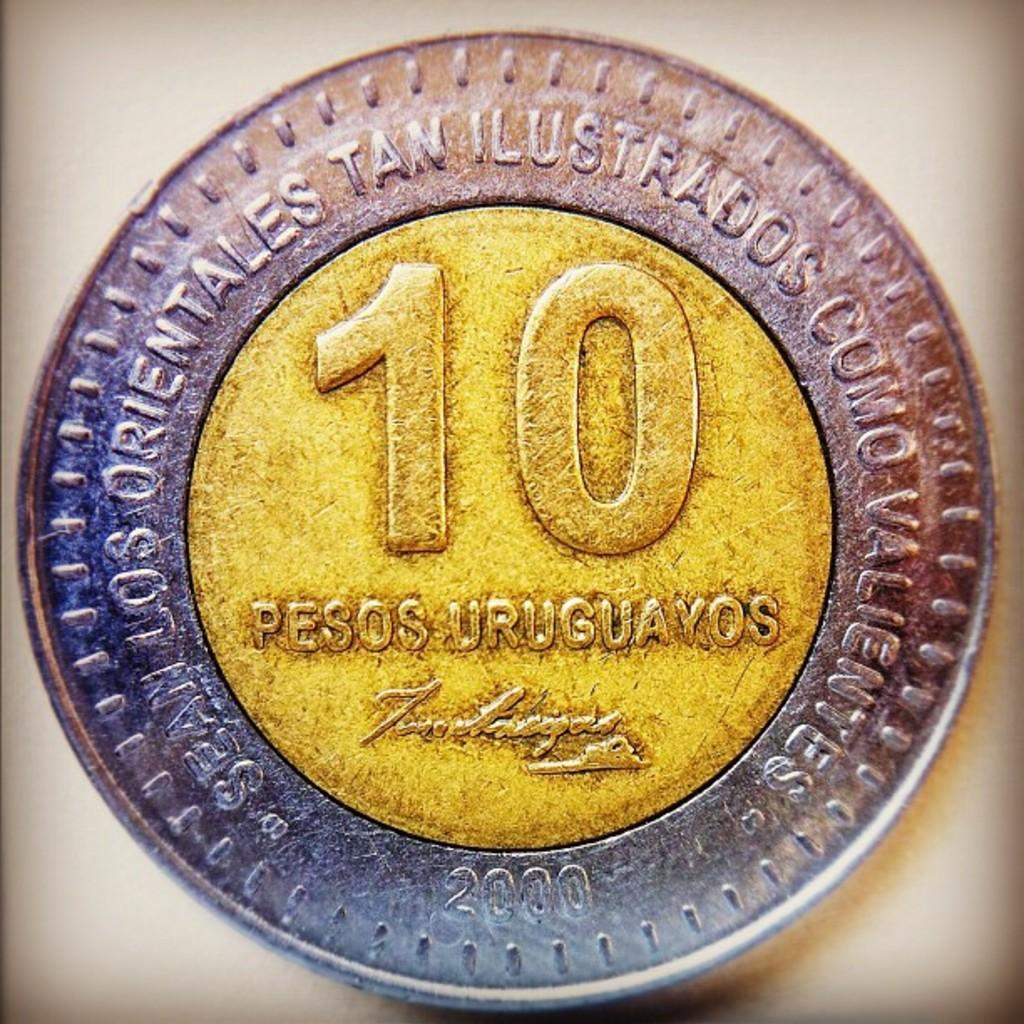<image>
Offer a succinct explanation of the picture presented. A 10 cent peso that is silver and yellow is being displayed. 